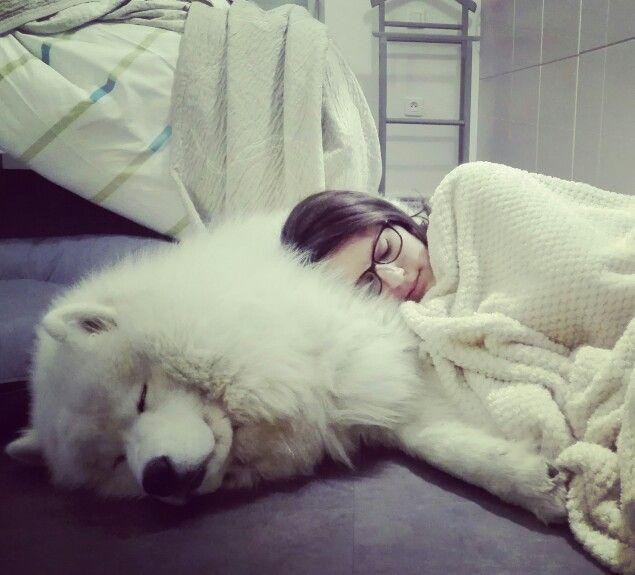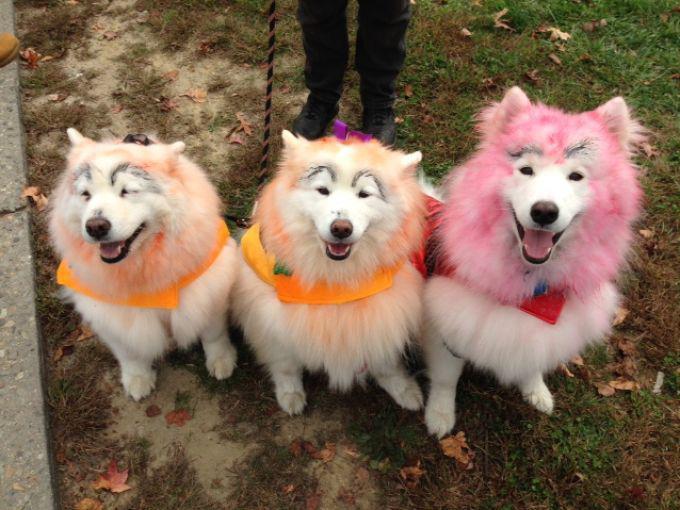The first image is the image on the left, the second image is the image on the right. For the images displayed, is the sentence "The left image shows a woman next to no less than one white dog" factually correct? Answer yes or no. Yes. The first image is the image on the left, the second image is the image on the right. Given the left and right images, does the statement "An image shows a trio of side-by-side white puppies on green grass, facing forward with not all paws on the ground." hold true? Answer yes or no. No. 